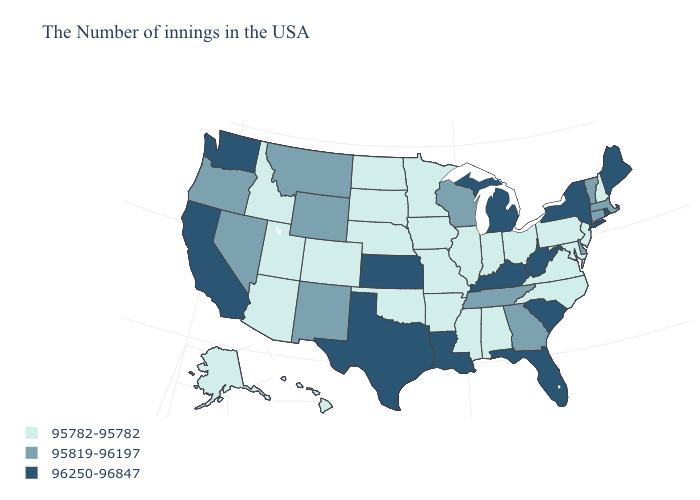What is the highest value in states that border Vermont?
Write a very short answer. 96250-96847. Name the states that have a value in the range 95819-96197?
Be succinct. Massachusetts, Vermont, Connecticut, Delaware, Georgia, Tennessee, Wisconsin, Wyoming, New Mexico, Montana, Nevada, Oregon. What is the lowest value in states that border North Dakota?
Keep it brief. 95782-95782. What is the value of North Carolina?
Answer briefly. 95782-95782. Does Oregon have a higher value than Missouri?
Keep it brief. Yes. Is the legend a continuous bar?
Quick response, please. No. What is the lowest value in states that border North Carolina?
Short answer required. 95782-95782. What is the value of Oregon?
Quick response, please. 95819-96197. What is the highest value in states that border Montana?
Give a very brief answer. 95819-96197. What is the value of Vermont?
Keep it brief. 95819-96197. Among the states that border Alabama , does Florida have the highest value?
Write a very short answer. Yes. Does the first symbol in the legend represent the smallest category?
Keep it brief. Yes. What is the value of Texas?
Keep it brief. 96250-96847. What is the highest value in states that border West Virginia?
Answer briefly. 96250-96847. 